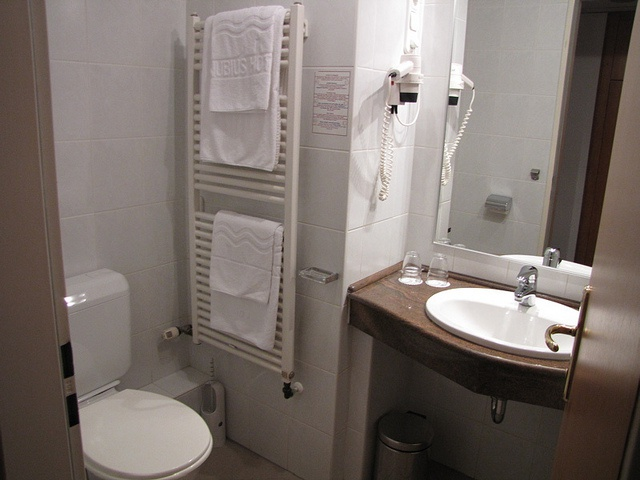Describe the objects in this image and their specific colors. I can see toilet in black, darkgray, and gray tones, sink in black, white, gray, and darkgray tones, hair drier in black, lightgray, darkgray, and gray tones, cup in black, darkgray, lightgray, and gray tones, and cup in black, darkgray, white, and gray tones in this image. 